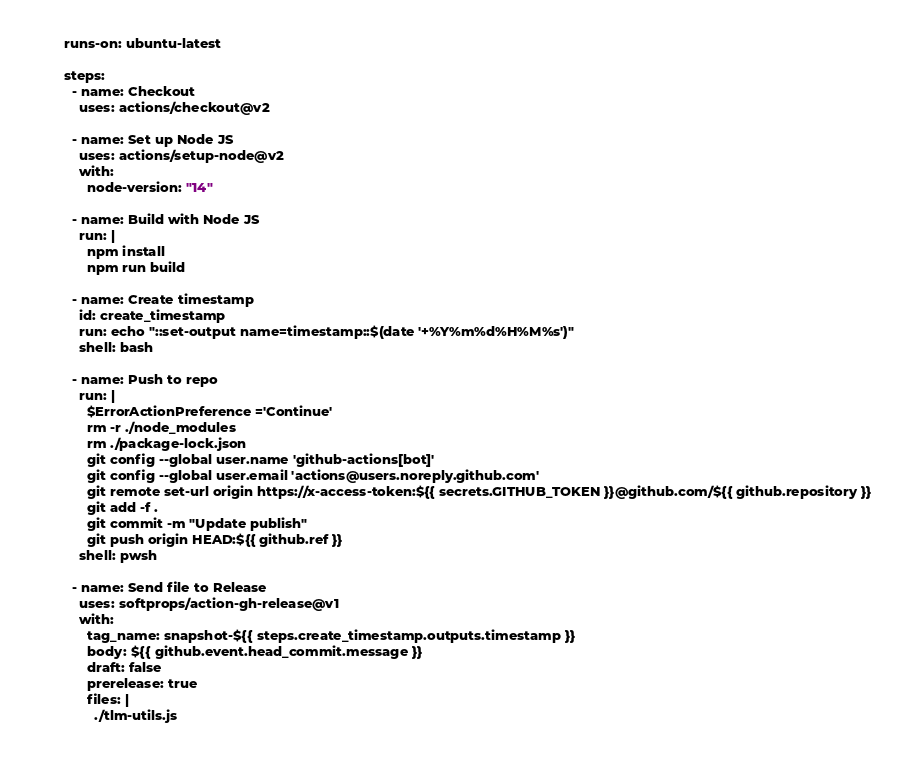<code> <loc_0><loc_0><loc_500><loc_500><_YAML_>    runs-on: ubuntu-latest

    steps:
      - name: Checkout
        uses: actions/checkout@v2

      - name: Set up Node JS
        uses: actions/setup-node@v2
        with:
          node-version: "14"

      - name: Build with Node JS
        run: |
          npm install
          npm run build

      - name: Create timestamp
        id: create_timestamp
        run: echo "::set-output name=timestamp::$(date '+%Y%m%d%H%M%s')"
        shell: bash

      - name: Push to repo
        run: |
          $ErrorActionPreference ='Continue'
          rm -r ./node_modules
          rm ./package-lock.json
          git config --global user.name 'github-actions[bot]'
          git config --global user.email 'actions@users.noreply.github.com'
          git remote set-url origin https://x-access-token:${{ secrets.GITHUB_TOKEN }}@github.com/${{ github.repository }}
          git add -f .
          git commit -m "Update publish"
          git push origin HEAD:${{ github.ref }}
        shell: pwsh

      - name: Send file to Release
        uses: softprops/action-gh-release@v1
        with:
          tag_name: snapshot-${{ steps.create_timestamp.outputs.timestamp }}
          body: ${{ github.event.head_commit.message }}
          draft: false
          prerelease: true
          files: |
            ./tlm-utils.js
</code> 